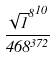Convert formula to latex. <formula><loc_0><loc_0><loc_500><loc_500>\frac { { \sqrt { 1 } ^ { 8 } } ^ { 1 0 } } { 4 6 8 ^ { 3 7 2 } }</formula> 